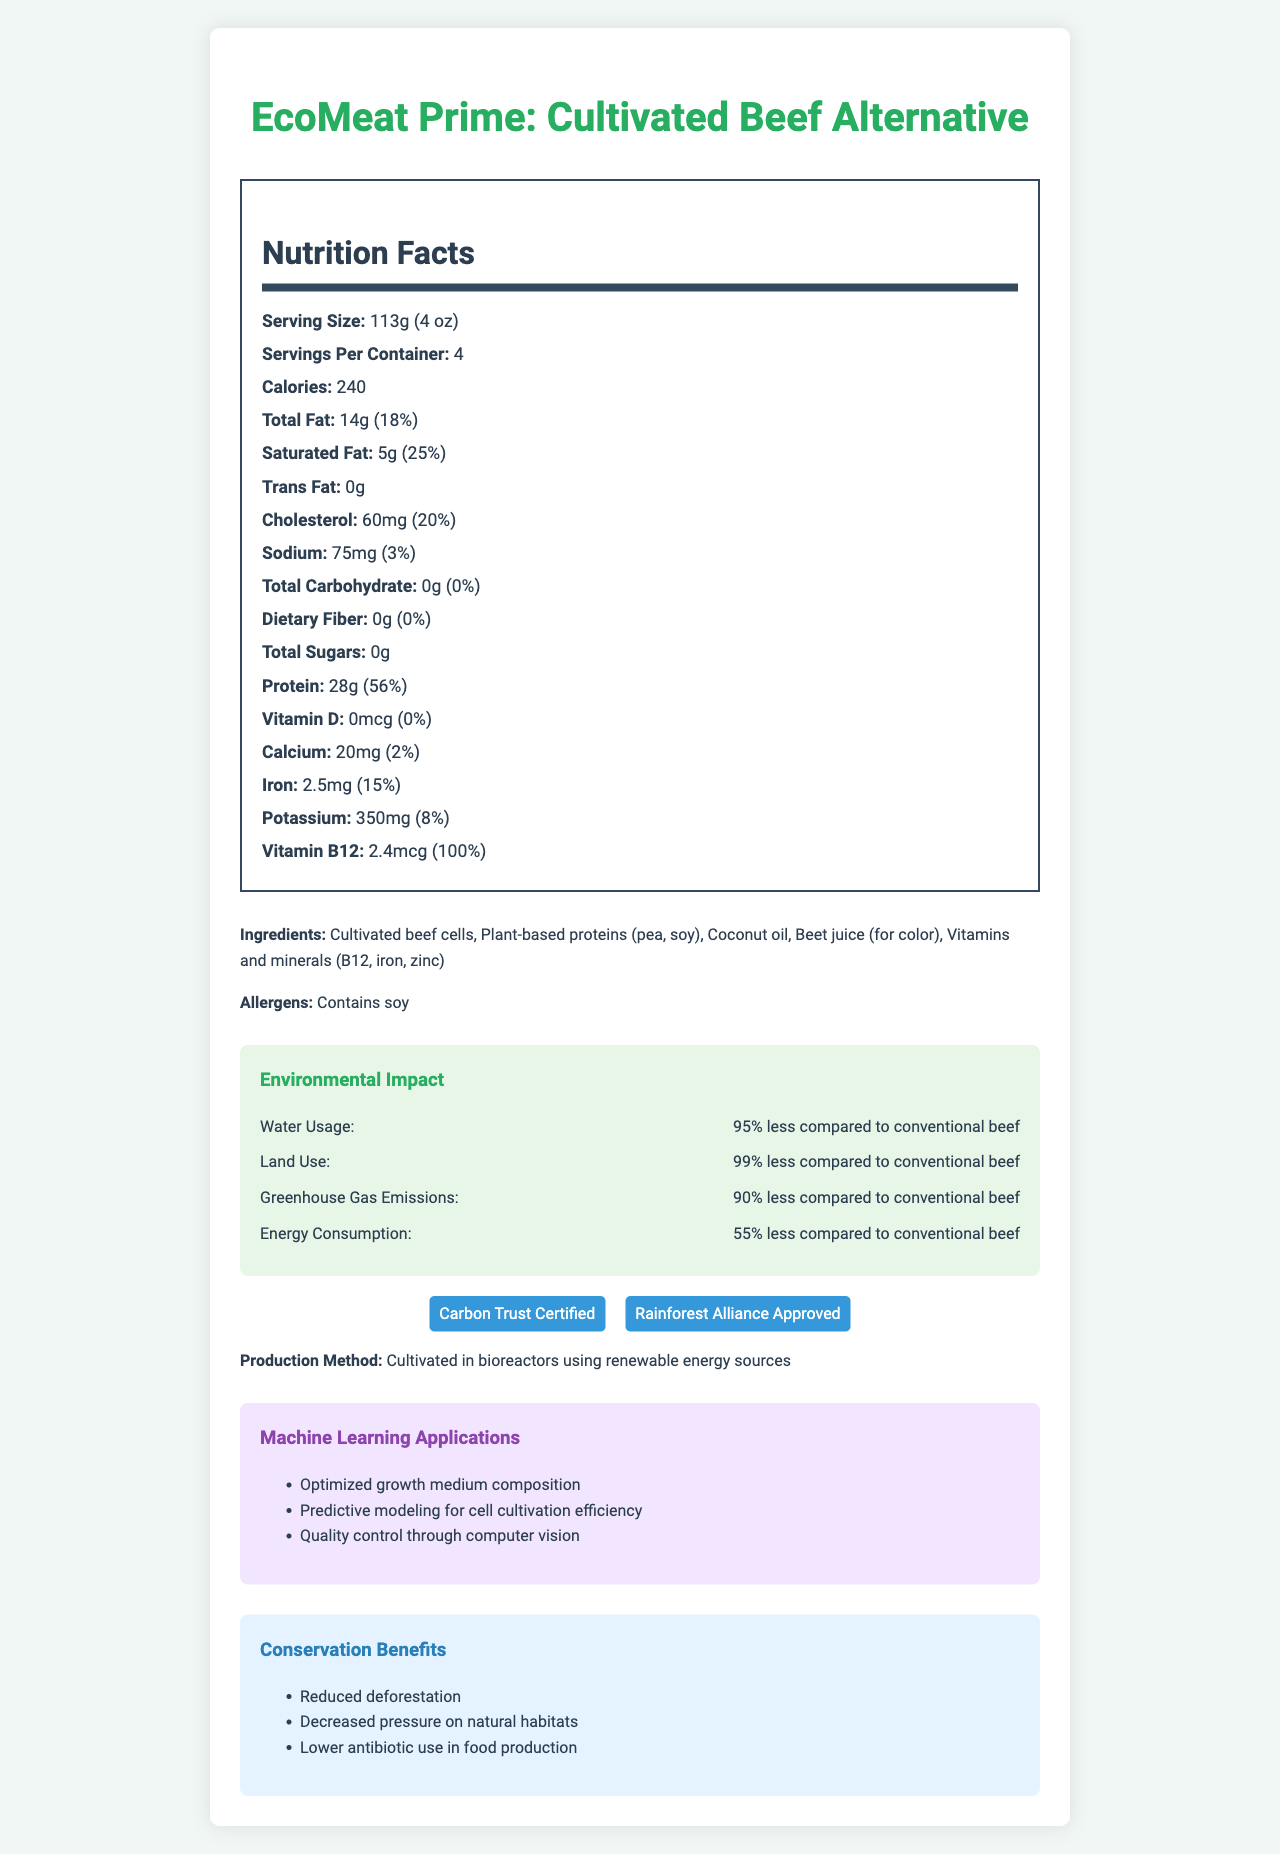what is the serving size? The serving size is explicitly stated under "Serving Size" in the Nutrition Facts section.
Answer: 113g (4 oz) how much protein is in one serving? The amount of protein is listed as 28g, which can be found directly in the Nutrition Facts section.
Answer: 28g what are the main ingredients in EcoMeat Prime? These ingredients are listed under the "Ingredients" section in the document.
Answer: Cultivated beef cells, Plant-based proteins (pea, soy), Coconut oil, Beet juice (for color), Vitamins and minerals (B12, iron, zinc) what certifications does this product have? The certifications are listed under the "Sustainability Certifications" sub-section.
Answer: Carbon Trust Certified, Rainforest Alliance Approved how much potassium is in a serving and what percentage of the daily value does this represent? The Nutrition Facts section lists Potassium as 350mg which is 8% of the daily value.
Answer: 350mg, 8% what is the environmental impact of EcoMeat Prime in terms of water usage? A. 55% less B. 90% less C. 95% less The Environmental Impact section states that water usage is 95% less compared to conventional beef.
Answer: C how much saturated fat does this product contain per serving? A. 2g B. 4g C. 5g D. 10g The Nutrition Facts section lists saturated fat as 5g.
Answer: C does this product contain any allergens? It contains soy, as listed under the "Allergens" section.
Answer: Yes is there any vitamin B12 in this product? The Nutrition Facts section lists 2.4mcg of Vitamin B12, which is 100% of the daily value.
Answer: Yes summarize the document The document provides a comprehensive overview of EcoMeat Prime, including its nutritional content, environmental impact, certifications, ingredients, allergens, production methods, and the role of machine learning in its cultivation.
Answer: EcoMeat Prime is a lab-grown beef alternative with detailed nutrition facts, including serving size, calories, and various nutrients. The product boasts substantial environmental benefits such as reduced water usage, land use, greenhouse gas emissions, and energy consumption compared to conventional beef. It is certified by the Carbon Trust and Rainforest Alliance. The document also highlights the use of machine learning in production for optimizing growth and quality, and conservation benefits like reduced deforestation and decreased habitat pressure. what is the energy consumption reduction of EcoMeat Prime compared to conventional beef? The Environmental Impact section states that the energy consumption of EcoMeat Prime is 55% less compared to conventional beef.
Answer: 55% less how does the document detail the use of machine learning? This information is found in the "Machine Learning Applications" section.
Answer: It lists applications such as optimized growth medium composition, predictive modeling for cell cultivation efficiency, and quality control through computer vision. how much iron is in a serving and what percentage of the daily value does it represent? The Nutrition Facts section lists iron as 2.5mg, which is 15% of the daily value.
Answer: 2.5mg, 15% what is the main production method of EcoMeat Prime? This information is detailed under the "Production Method" section.
Answer: Cultivated in bioreactors using renewable energy sources what percentage of the daily value of protein does one serving provide? The Nutrition Facts section lists the protein content as 28g, which provides 56% of the daily value.
Answer: 56% what is the price of EcoMeat Prime per container? The document does not provide information about the price of the product.
Answer: Not enough information 